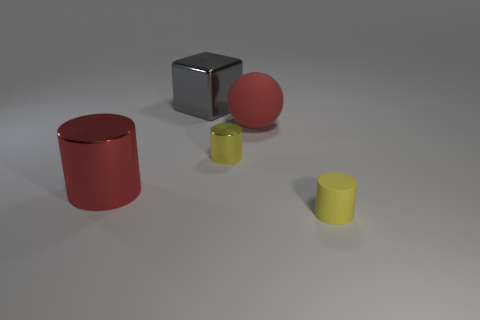There is a thing left of the large gray metallic block on the right side of the red metal cylinder; what number of gray shiny cubes are in front of it?
Offer a very short reply. 0. What is the material of the large object that is the same color as the large ball?
Give a very brief answer. Metal. Is there anything else that is the same shape as the large gray metal object?
Provide a succinct answer. No. What number of objects are either large objects to the left of the sphere or big gray objects?
Your answer should be compact. 2. Do the tiny thing in front of the yellow metal object and the large cube have the same color?
Give a very brief answer. No. There is a big metallic object that is right of the big metal thing in front of the big matte ball; what is its shape?
Your response must be concise. Cube. Is the number of red objects that are on the right side of the yellow rubber cylinder less than the number of small yellow shiny cylinders that are behind the large cube?
Provide a short and direct response. No. What size is the yellow metal thing that is the same shape as the small matte thing?
Ensure brevity in your answer.  Small. Is there any other thing that has the same size as the yellow rubber cylinder?
Your response must be concise. Yes. How many things are either matte cylinders that are right of the big gray metal object or small yellow objects right of the tiny metallic cylinder?
Your answer should be compact. 1. 